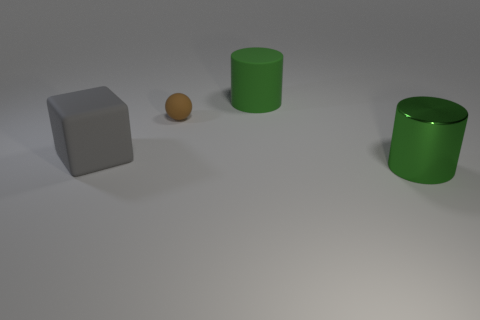Add 1 large cubes. How many objects exist? 5 Subtract all blocks. How many objects are left? 3 Subtract all purple metallic spheres. Subtract all tiny brown objects. How many objects are left? 3 Add 1 matte cylinders. How many matte cylinders are left? 2 Add 1 small things. How many small things exist? 2 Subtract 0 blue cylinders. How many objects are left? 4 